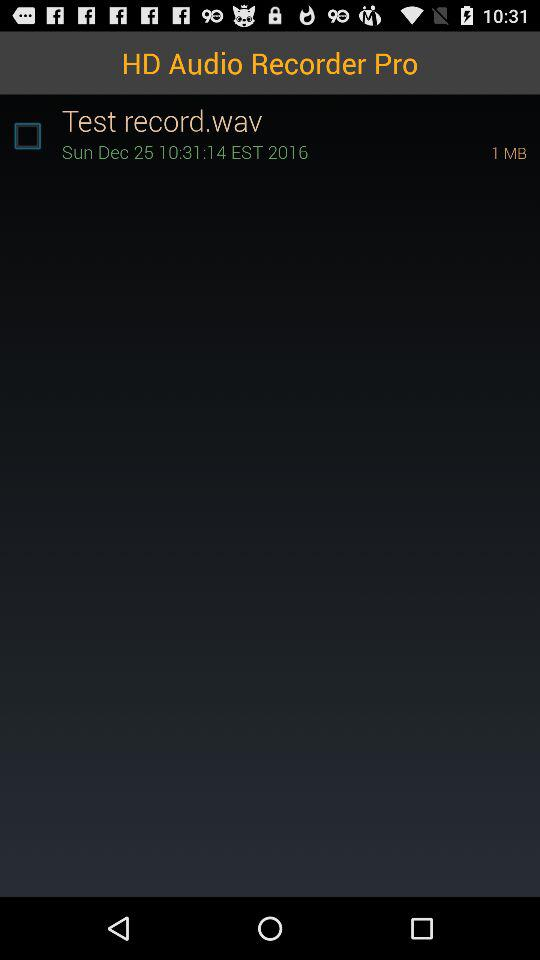What is the day on December 25th? The day is Sunday. 